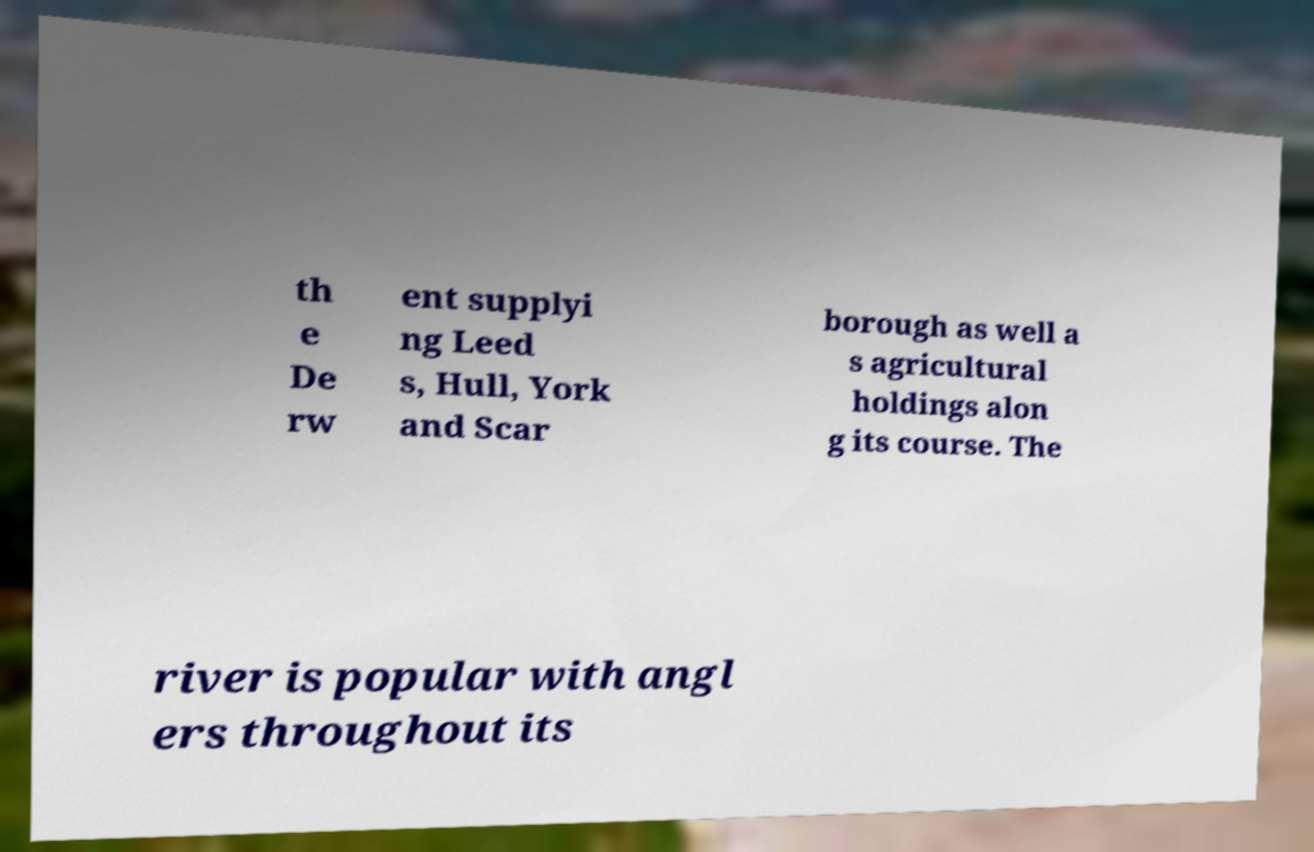There's text embedded in this image that I need extracted. Can you transcribe it verbatim? th e De rw ent supplyi ng Leed s, Hull, York and Scar borough as well a s agricultural holdings alon g its course. The river is popular with angl ers throughout its 